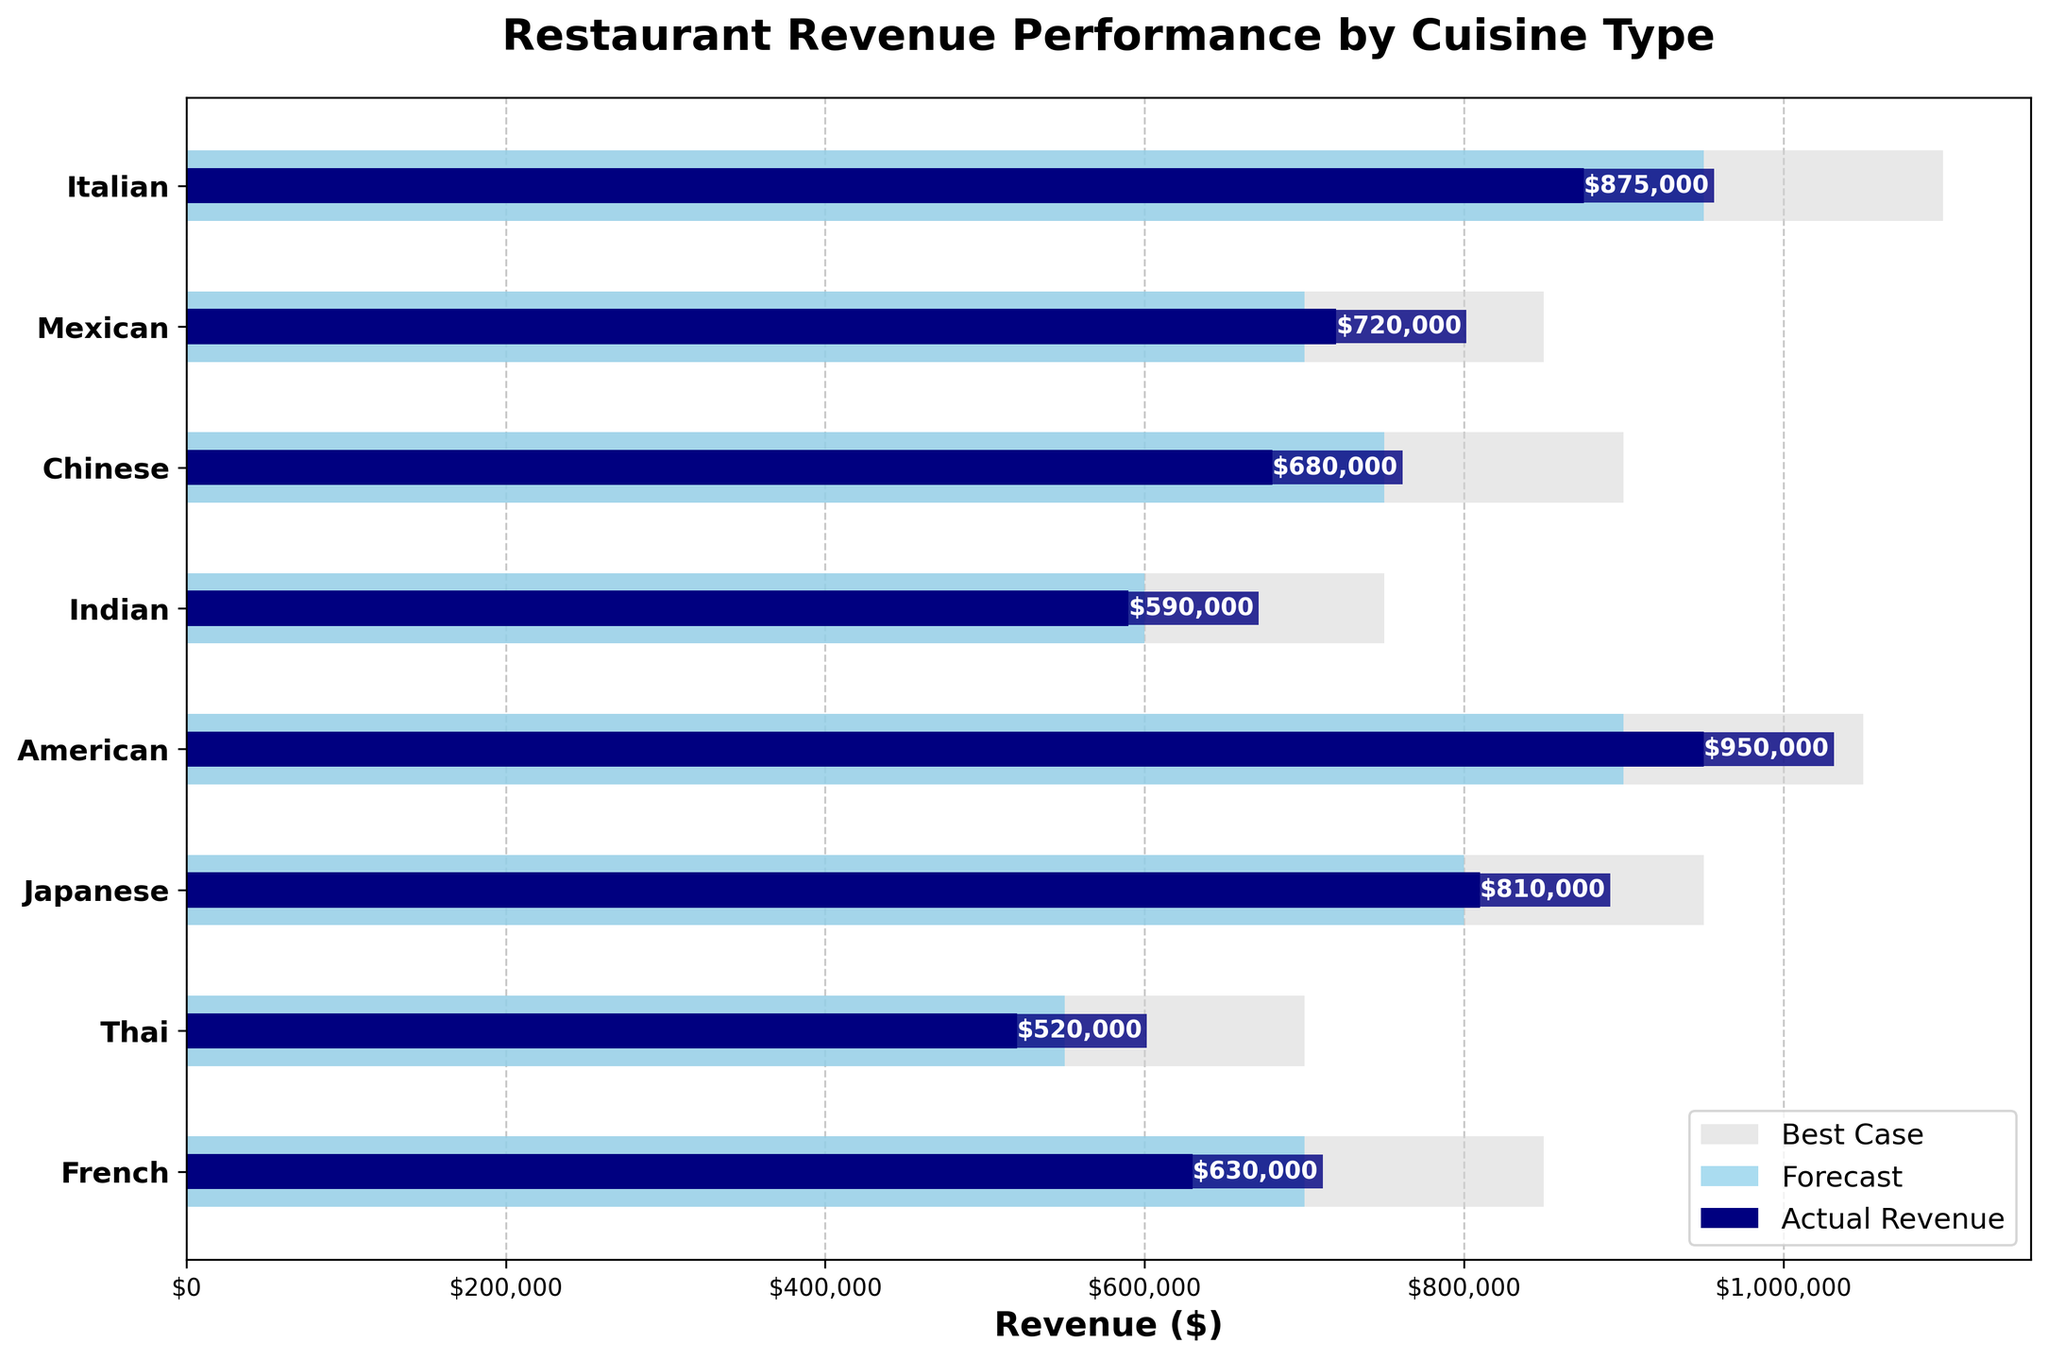What is the title of the figure? The title is displayed at the top of the figure and often shows the main subject of the plot. Here, it clearly says what the figure is about.
Answer: Restaurant Revenue Performance by Cuisine Type How many cuisine types are displayed in the plot? You can count the number of bars representing different cuisine types on the y-axis.
Answer: 8 Which cuisine type had the highest actual revenue? By looking at the length of the actual revenue bars, you can identify the longest one. The darkest blue bar represents actual revenue.
Answer: American Which cuisine type had the lowest forecasted revenue? By comparing the length of the forecast bars (light blue), you can identify the shortest one.
Answer: Thai Did Mexican cuisine exceed its forecasted revenue? Check if the actual revenue bar (darkest blue) for Mexican cuisine surpasses the forecasted revenue bar (light blue).
Answer: Yes What was the difference between the best case and actual revenue for Italian cuisine? Subtract the actual revenue from the best case revenue for Italian cuisine: \$1,100,000 - \$875,000.
Answer: \$225,000 For which cuisine did the actual revenue fall the most short of the best case scenario? Compare the gaps between best case (light grey) and actual revenues (dark blue) across the cuisines and find the largest gap.
Answer: Chinese Which cuisine nearly hit its forecasted revenue? Look for cuisines where the actual revenue bar (dark blue) closely matches the forecasted revenue bar (light blue).
Answer: Japanese What is the total actual revenue for Indian and French cuisines combined? Add the actual revenues for Indian and French cuisines: \$590,000 + \$630,000.
Answer: \$1,220,000 Is there any cuisine where actual revenue exceeded the best case scenario? Compare the actual revenue bars (dark blue) against the best case bars (light grey) for all cuisines to see if any actual revenue bar exceeds a best case bar.
Answer: No 